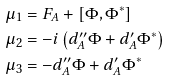Convert formula to latex. <formula><loc_0><loc_0><loc_500><loc_500>\mu _ { 1 } & = F _ { A } + [ \Phi , \Phi ^ { * } ] \\ \mu _ { 2 } & = - i \left ( d _ { A } ^ { \prime \prime } \Phi + d _ { A } ^ { \prime } \Phi ^ { * } \right ) \\ \mu _ { 3 } & = - d _ { A } ^ { \prime \prime } \Phi + d _ { A } ^ { \prime } \Phi ^ { * }</formula> 